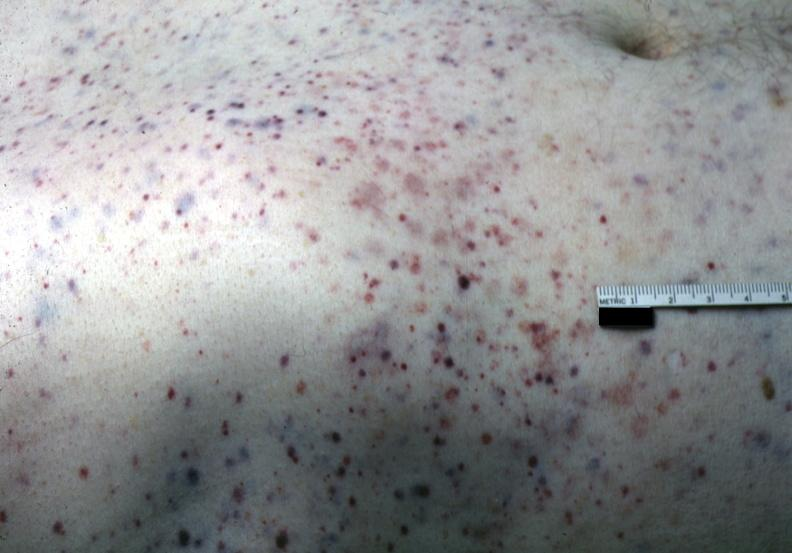does pancreas show white skin with multiple lesions?
Answer the question using a single word or phrase. No 